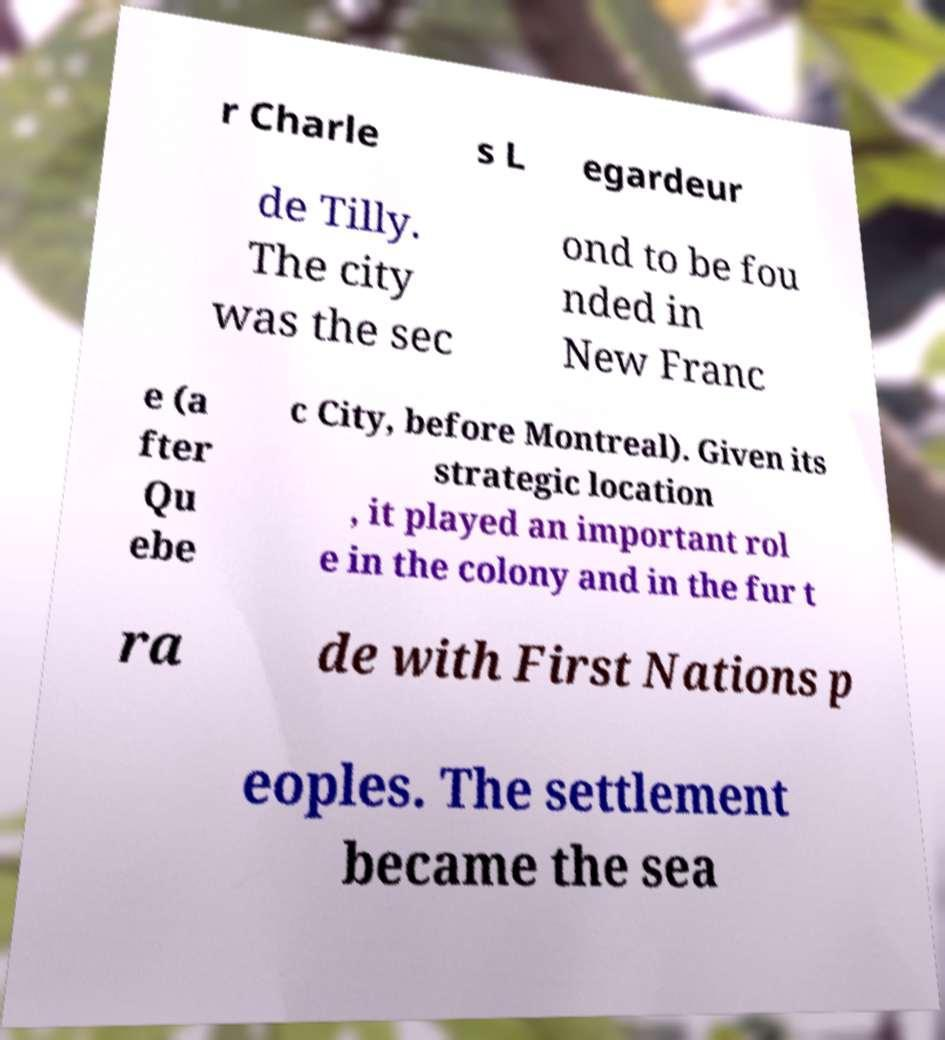I need the written content from this picture converted into text. Can you do that? r Charle s L egardeur de Tilly. The city was the sec ond to be fou nded in New Franc e (a fter Qu ebe c City, before Montreal). Given its strategic location , it played an important rol e in the colony and in the fur t ra de with First Nations p eoples. The settlement became the sea 